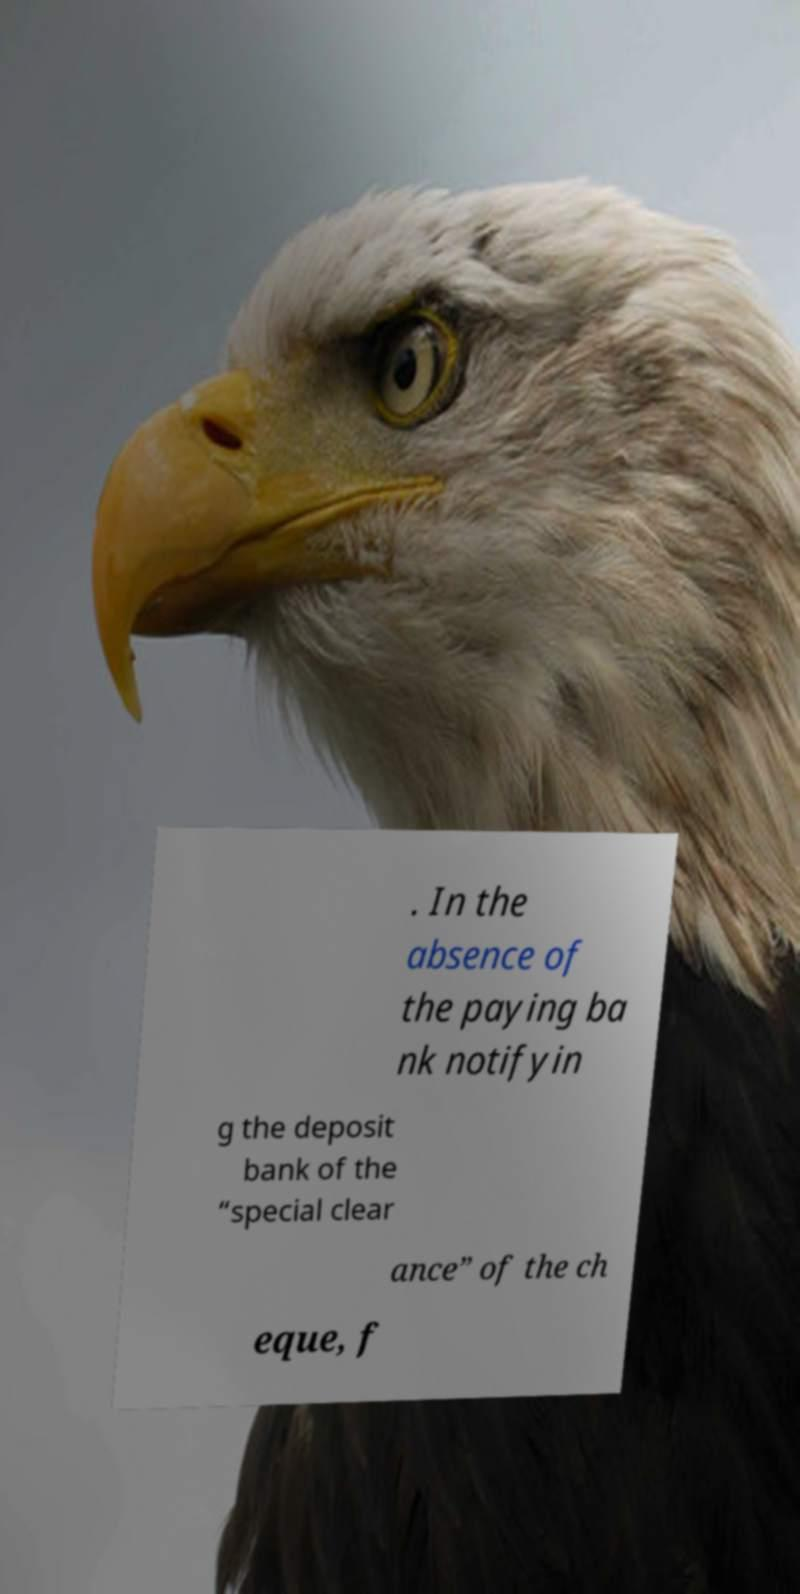For documentation purposes, I need the text within this image transcribed. Could you provide that? . In the absence of the paying ba nk notifyin g the deposit bank of the “special clear ance” of the ch eque, f 